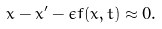Convert formula to latex. <formula><loc_0><loc_0><loc_500><loc_500>x - x ^ { \prime } - \epsilon f ( \bar { x } , t ) \approx 0 .</formula> 